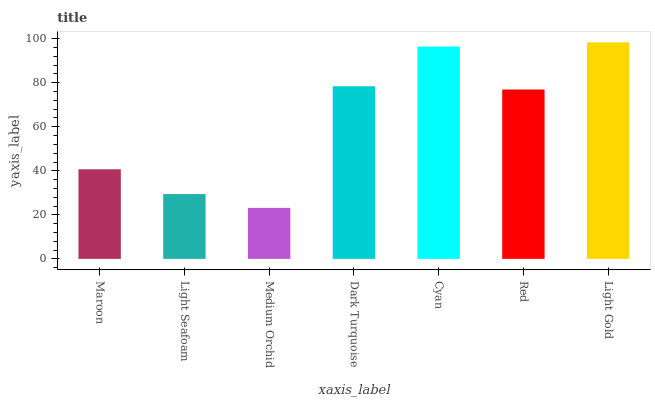Is Medium Orchid the minimum?
Answer yes or no. Yes. Is Light Gold the maximum?
Answer yes or no. Yes. Is Light Seafoam the minimum?
Answer yes or no. No. Is Light Seafoam the maximum?
Answer yes or no. No. Is Maroon greater than Light Seafoam?
Answer yes or no. Yes. Is Light Seafoam less than Maroon?
Answer yes or no. Yes. Is Light Seafoam greater than Maroon?
Answer yes or no. No. Is Maroon less than Light Seafoam?
Answer yes or no. No. Is Red the high median?
Answer yes or no. Yes. Is Red the low median?
Answer yes or no. Yes. Is Light Seafoam the high median?
Answer yes or no. No. Is Light Gold the low median?
Answer yes or no. No. 